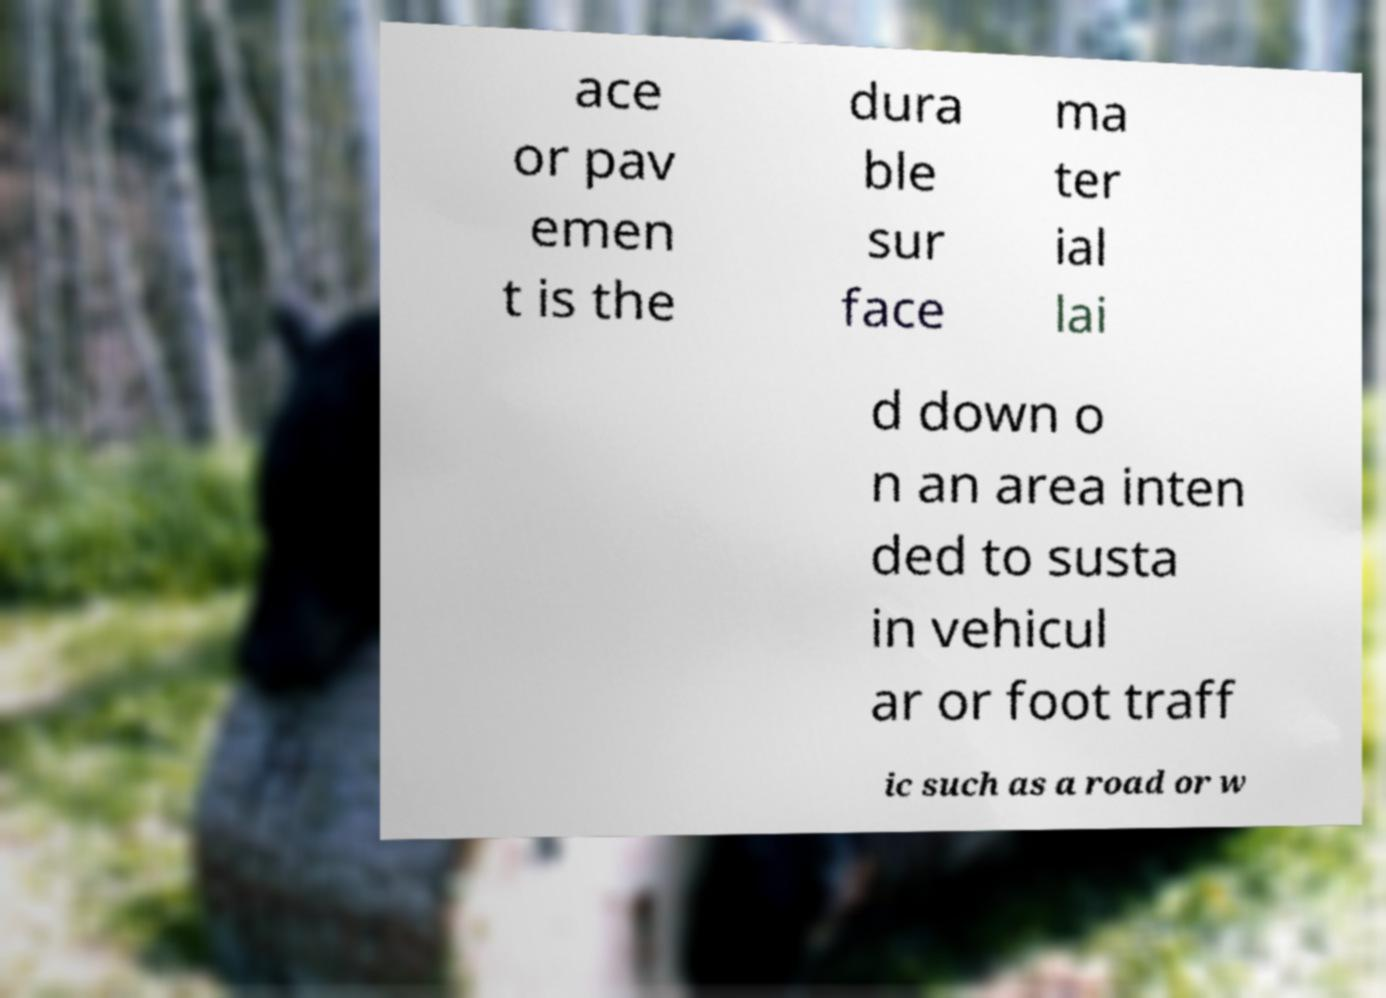Please identify and transcribe the text found in this image. ace or pav emen t is the dura ble sur face ma ter ial lai d down o n an area inten ded to susta in vehicul ar or foot traff ic such as a road or w 